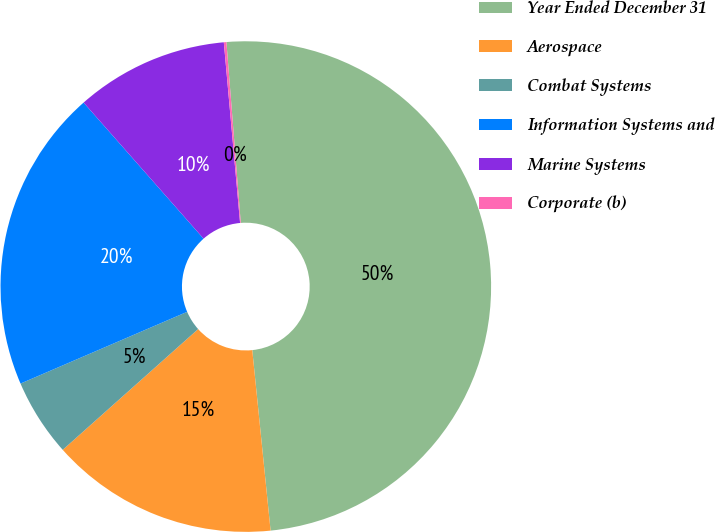<chart> <loc_0><loc_0><loc_500><loc_500><pie_chart><fcel>Year Ended December 31<fcel>Aerospace<fcel>Combat Systems<fcel>Information Systems and<fcel>Marine Systems<fcel>Corporate (b)<nl><fcel>49.65%<fcel>15.02%<fcel>5.12%<fcel>19.97%<fcel>10.07%<fcel>0.17%<nl></chart> 